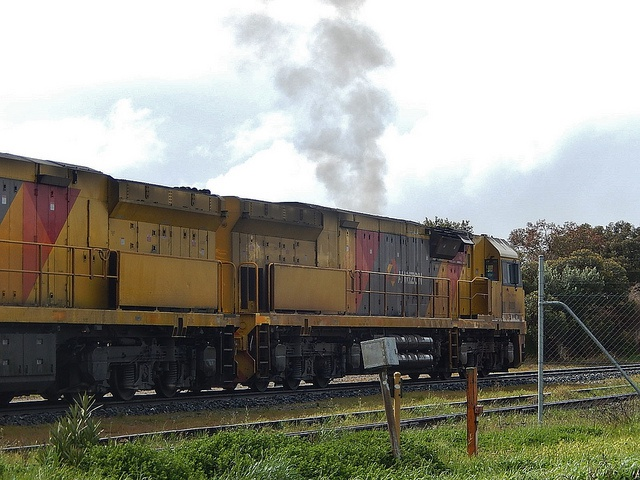Describe the objects in this image and their specific colors. I can see a train in white, black, olive, gray, and maroon tones in this image. 